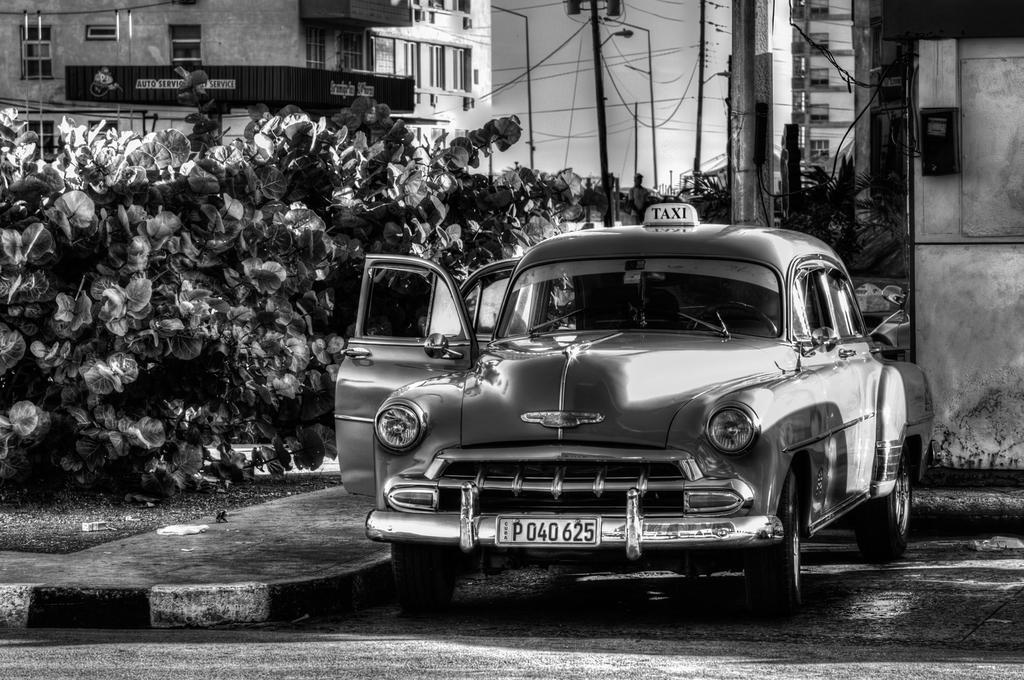Please provide a concise description of this image. It is black and white image. In this image, we can see a car is parked on the path. Background we can see few plants, buildings, poles, wires, walls, windows and some objects. Here we can see a person is standing. 